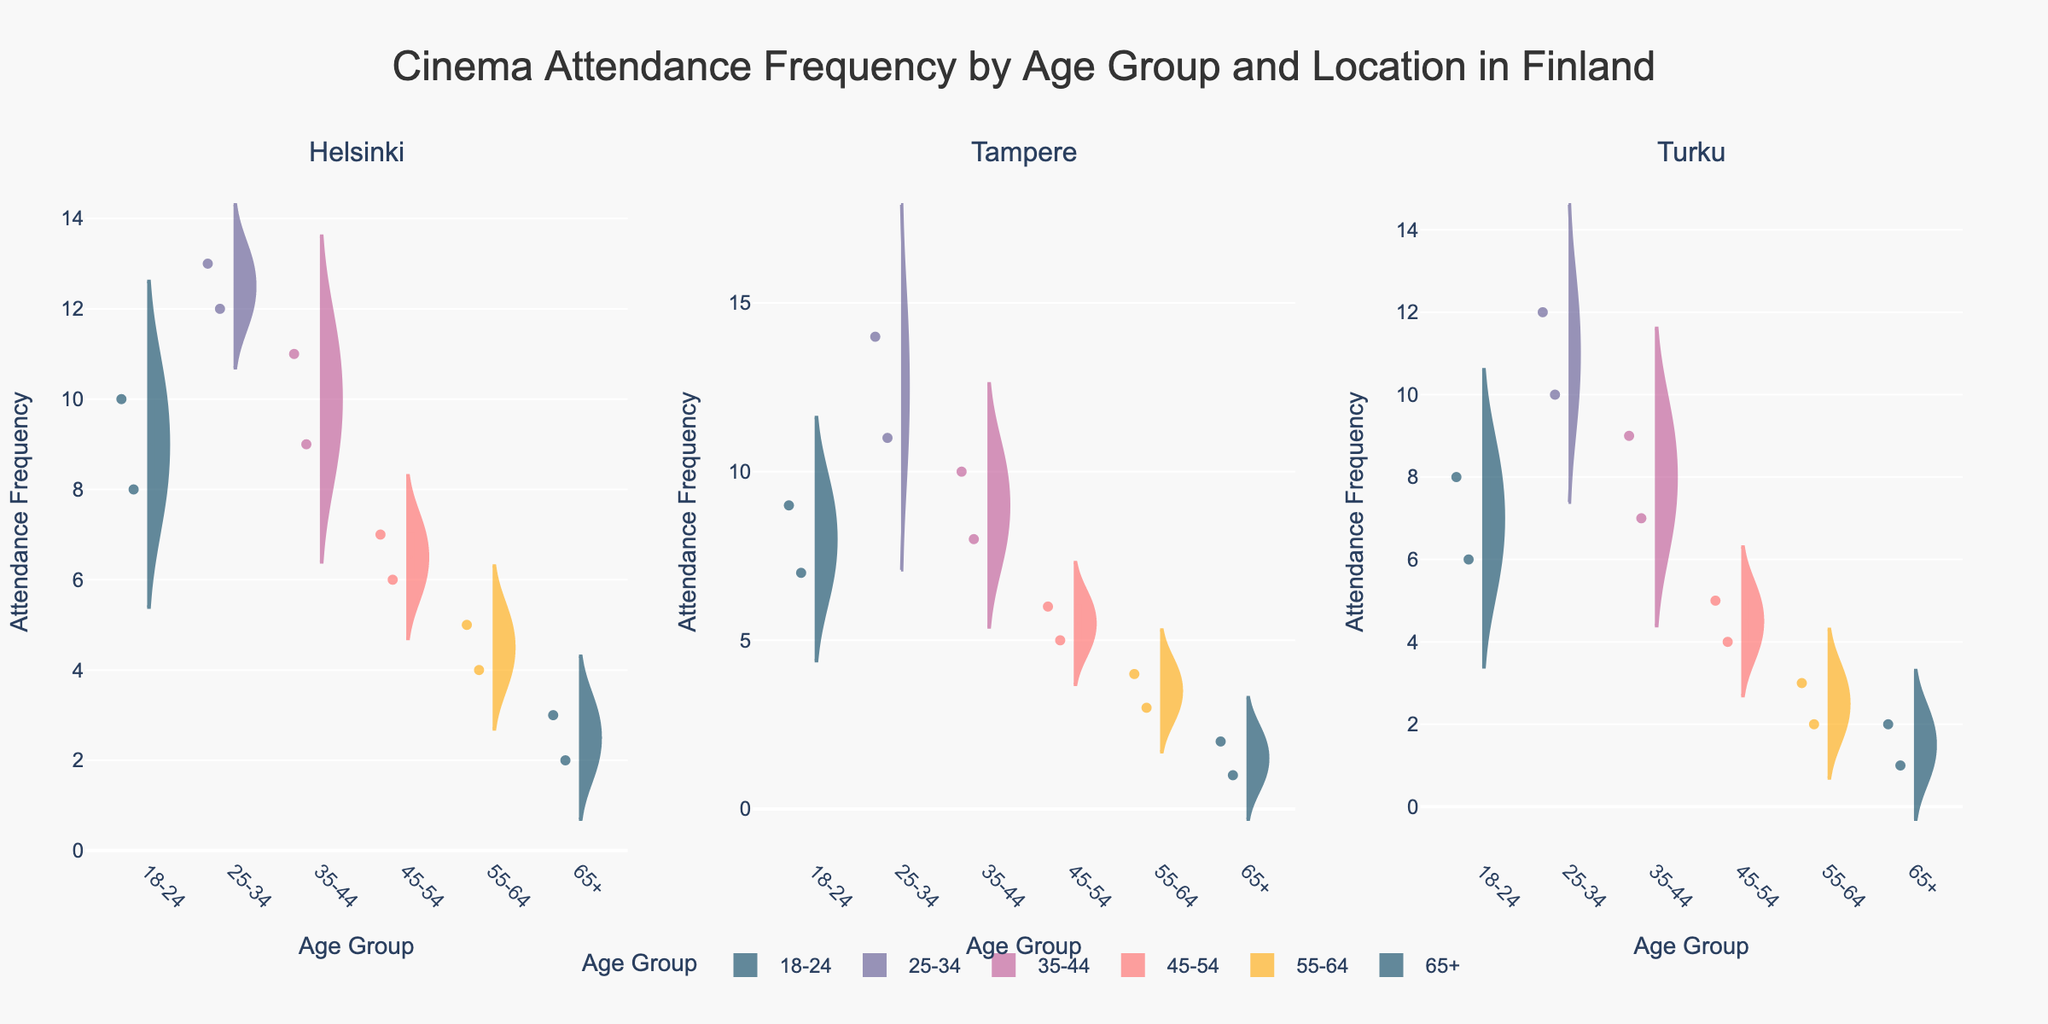What's the title of the figure? The title of the figure is located at the top center. It summarizes the subject of the plot, focusing on cinema attendance frequency by age group and location in Finland.
Answer: Cinema Attendance Frequency by Age Group and Location in Finland Which age group has the highest attendance frequency in Helsinki? To find this, look at the Helsinki subplot and identify which age group’s violin plot has the highest median line. The 25-34 age group shows the highest frequency.
Answer: 25-34 How does the attendance frequency distribution in Turku for the 45-54 age group compare to the 55-64 age group? Compare the violin widths and the positions of the median lines for these two age groups in the Turku subplot. The 45-54 age group has a slightly higher median and wider distribution than the 55-64 age group.
Answer: The 45-54 age group has a higher and wider distribution than the 55-64 age group What is the overall trend in attendance frequency across different age groups in Tampere? Look at the Tampere subplot and observe the median lines. There is a decreasing trend in median attendance frequency as we move from younger to older age groups.
Answer: Decreasing trend with age Which gender shows more outliers in the 18-24 age group in Helsinki? Check the Helsinki subplot for the 18-24 age group and see the distribution of individual points for males and females. Females show more outliers.
Answer: Females What’s the range of the attendance frequency for the 35-44 age group in Tampere? For the 35-44 age group in the Tampere subplot, look at the maximum and minimum points within the violin plot's whiskers. The range can be calculated as max (10) - min (8).
Answer: 2 Compare the mean attendance frequency between Turku and Helsinki for the 25-34 age group. Look at the median lines and the mean line (usually highlighted within the box). Helsinki shows a mean attendance slightly higher than Turku for the 25-34 age group.
Answer: Helsinki has a higher mean Are there any age groups with no outliers in Turku? In the Turku subplot, observe if there are any individual points that fall outside the main body of the violin plots. All age groups have some outliers.
Answer: No Which city has the widest range of attendance frequencies for the 55-64 age group? Examine the spread of the violin plots for the 55-64 age group across all three subplots (Helsinki, Tampere, Turku). Helsinki has the widest range.
Answer: Helsinki 